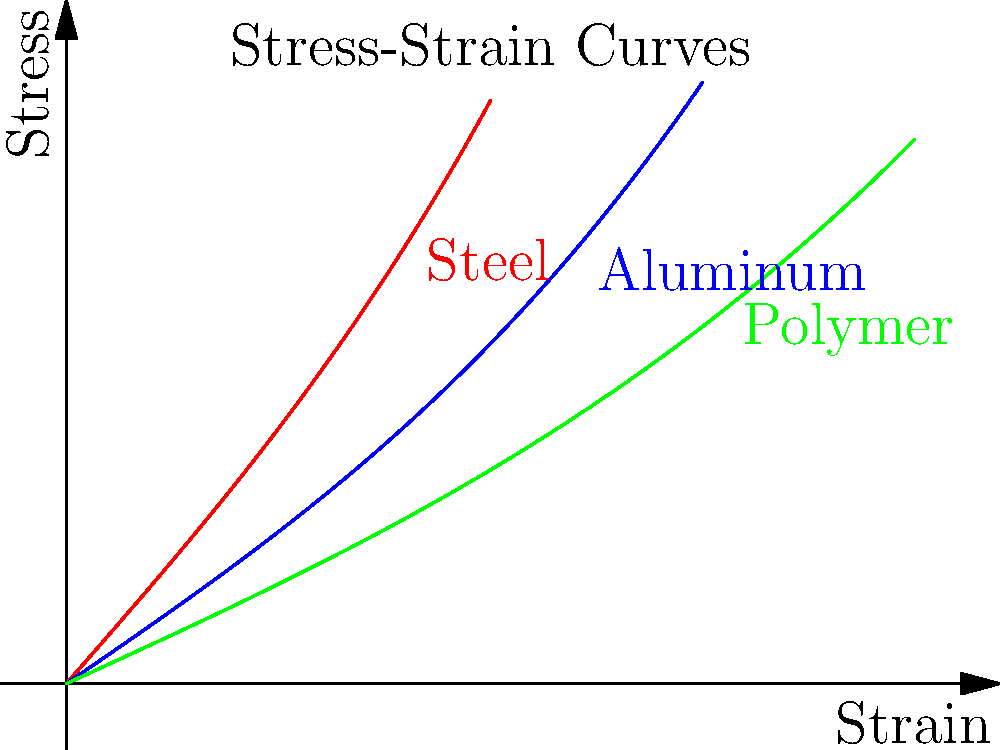As a software engineer developing a document management platform for engineering applications, you need to implement a feature for analyzing stress-strain curves. Given the stress-strain curves for steel, aluminum, and a polymer shown in the graph, which material exhibits the highest stiffness (Young's modulus)? To determine which material has the highest stiffness (Young's modulus), we need to follow these steps:

1. Recall that Young's modulus (E) is defined as the ratio of stress (σ) to strain (ε) in the linear elastic region:

   $$ E = \frac{\sigma}{\varepsilon} $$

2. In a stress-strain curve, Young's modulus is represented by the slope of the initial linear portion of the curve.

3. Analyze each curve:
   
   a. Steel (red curve): Has the steepest initial slope.
   b. Aluminum (blue curve): Has a moderate initial slope.
   c. Polymer (green curve): Has the shallowest initial slope.

4. Compare the initial slopes:
   
   Steel > Aluminum > Polymer

5. The material with the steepest initial slope (highest Young's modulus) is the stiffest.

Therefore, based on the stress-strain curves provided, steel exhibits the highest stiffness (Young's modulus).
Answer: Steel 